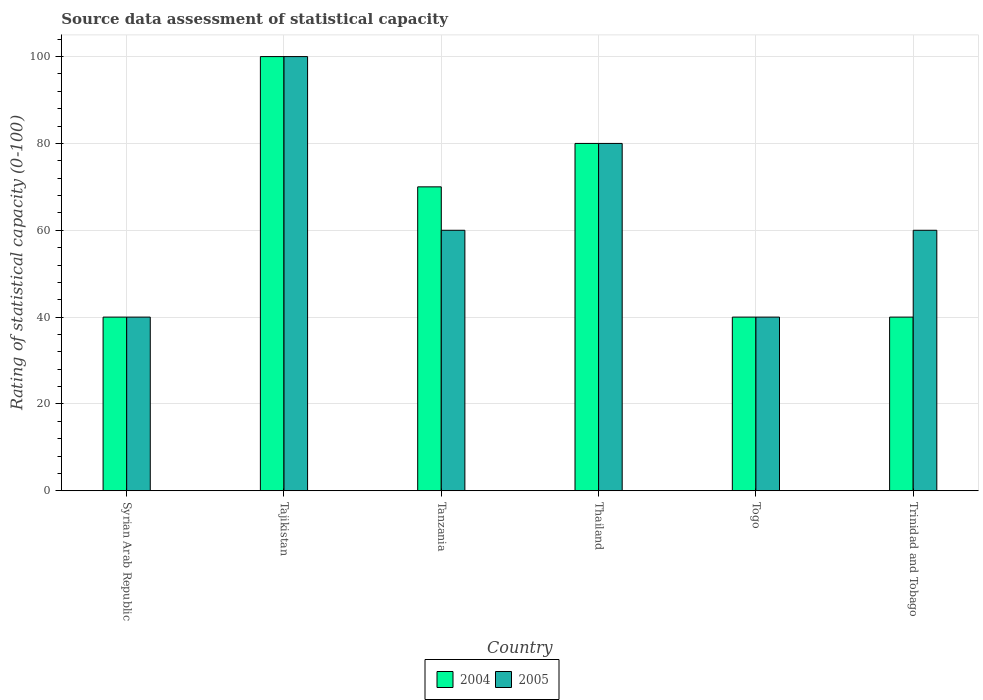Are the number of bars per tick equal to the number of legend labels?
Provide a short and direct response. Yes. What is the label of the 4th group of bars from the left?
Your answer should be very brief. Thailand. In which country was the rating of statistical capacity in 2005 maximum?
Give a very brief answer. Tajikistan. In which country was the rating of statistical capacity in 2004 minimum?
Keep it short and to the point. Syrian Arab Republic. What is the total rating of statistical capacity in 2005 in the graph?
Offer a very short reply. 380. What is the average rating of statistical capacity in 2004 per country?
Offer a terse response. 61.67. What is the ratio of the rating of statistical capacity in 2004 in Thailand to that in Trinidad and Tobago?
Provide a short and direct response. 2. Is the difference between the rating of statistical capacity in 2005 in Tajikistan and Thailand greater than the difference between the rating of statistical capacity in 2004 in Tajikistan and Thailand?
Provide a short and direct response. No. What is the difference between the highest and the second highest rating of statistical capacity in 2004?
Offer a very short reply. -20. Is the sum of the rating of statistical capacity in 2004 in Tajikistan and Thailand greater than the maximum rating of statistical capacity in 2005 across all countries?
Give a very brief answer. Yes. What does the 2nd bar from the left in Thailand represents?
Provide a succinct answer. 2005. How many bars are there?
Ensure brevity in your answer.  12. Are all the bars in the graph horizontal?
Your answer should be very brief. No. What is the difference between two consecutive major ticks on the Y-axis?
Give a very brief answer. 20. Are the values on the major ticks of Y-axis written in scientific E-notation?
Provide a succinct answer. No. Does the graph contain any zero values?
Give a very brief answer. No. Where does the legend appear in the graph?
Make the answer very short. Bottom center. How are the legend labels stacked?
Offer a terse response. Horizontal. What is the title of the graph?
Your answer should be very brief. Source data assessment of statistical capacity. Does "1964" appear as one of the legend labels in the graph?
Make the answer very short. No. What is the label or title of the Y-axis?
Your response must be concise. Rating of statistical capacity (0-100). What is the Rating of statistical capacity (0-100) in 2005 in Syrian Arab Republic?
Ensure brevity in your answer.  40. What is the Rating of statistical capacity (0-100) in 2004 in Tajikistan?
Provide a succinct answer. 100. What is the Rating of statistical capacity (0-100) of 2004 in Thailand?
Your answer should be very brief. 80. What is the Rating of statistical capacity (0-100) of 2005 in Thailand?
Keep it short and to the point. 80. What is the Rating of statistical capacity (0-100) of 2004 in Togo?
Keep it short and to the point. 40. What is the Rating of statistical capacity (0-100) in 2005 in Togo?
Your answer should be compact. 40. Across all countries, what is the minimum Rating of statistical capacity (0-100) in 2005?
Offer a terse response. 40. What is the total Rating of statistical capacity (0-100) in 2004 in the graph?
Offer a very short reply. 370. What is the total Rating of statistical capacity (0-100) in 2005 in the graph?
Your answer should be compact. 380. What is the difference between the Rating of statistical capacity (0-100) in 2004 in Syrian Arab Republic and that in Tajikistan?
Your answer should be very brief. -60. What is the difference between the Rating of statistical capacity (0-100) in 2005 in Syrian Arab Republic and that in Tajikistan?
Offer a terse response. -60. What is the difference between the Rating of statistical capacity (0-100) of 2004 in Syrian Arab Republic and that in Tanzania?
Provide a short and direct response. -30. What is the difference between the Rating of statistical capacity (0-100) in 2005 in Syrian Arab Republic and that in Thailand?
Provide a succinct answer. -40. What is the difference between the Rating of statistical capacity (0-100) of 2005 in Syrian Arab Republic and that in Togo?
Your answer should be compact. 0. What is the difference between the Rating of statistical capacity (0-100) of 2004 in Syrian Arab Republic and that in Trinidad and Tobago?
Ensure brevity in your answer.  0. What is the difference between the Rating of statistical capacity (0-100) of 2005 in Syrian Arab Republic and that in Trinidad and Tobago?
Your answer should be compact. -20. What is the difference between the Rating of statistical capacity (0-100) in 2004 in Tajikistan and that in Tanzania?
Give a very brief answer. 30. What is the difference between the Rating of statistical capacity (0-100) of 2005 in Tajikistan and that in Tanzania?
Give a very brief answer. 40. What is the difference between the Rating of statistical capacity (0-100) in 2005 in Tajikistan and that in Togo?
Provide a succinct answer. 60. What is the difference between the Rating of statistical capacity (0-100) in 2004 in Tajikistan and that in Trinidad and Tobago?
Make the answer very short. 60. What is the difference between the Rating of statistical capacity (0-100) of 2005 in Tajikistan and that in Trinidad and Tobago?
Your response must be concise. 40. What is the difference between the Rating of statistical capacity (0-100) of 2005 in Tanzania and that in Togo?
Your response must be concise. 20. What is the difference between the Rating of statistical capacity (0-100) in 2005 in Tanzania and that in Trinidad and Tobago?
Your answer should be compact. 0. What is the difference between the Rating of statistical capacity (0-100) of 2004 in Thailand and that in Trinidad and Tobago?
Give a very brief answer. 40. What is the difference between the Rating of statistical capacity (0-100) of 2005 in Thailand and that in Trinidad and Tobago?
Your answer should be compact. 20. What is the difference between the Rating of statistical capacity (0-100) of 2004 in Togo and that in Trinidad and Tobago?
Offer a very short reply. 0. What is the difference between the Rating of statistical capacity (0-100) of 2004 in Syrian Arab Republic and the Rating of statistical capacity (0-100) of 2005 in Tajikistan?
Keep it short and to the point. -60. What is the difference between the Rating of statistical capacity (0-100) of 2004 in Syrian Arab Republic and the Rating of statistical capacity (0-100) of 2005 in Thailand?
Provide a succinct answer. -40. What is the difference between the Rating of statistical capacity (0-100) in 2004 in Syrian Arab Republic and the Rating of statistical capacity (0-100) in 2005 in Togo?
Give a very brief answer. 0. What is the difference between the Rating of statistical capacity (0-100) of 2004 in Tajikistan and the Rating of statistical capacity (0-100) of 2005 in Tanzania?
Provide a succinct answer. 40. What is the difference between the Rating of statistical capacity (0-100) in 2004 in Tajikistan and the Rating of statistical capacity (0-100) in 2005 in Trinidad and Tobago?
Offer a terse response. 40. What is the difference between the Rating of statistical capacity (0-100) in 2004 in Tanzania and the Rating of statistical capacity (0-100) in 2005 in Togo?
Your answer should be compact. 30. What is the difference between the Rating of statistical capacity (0-100) of 2004 in Togo and the Rating of statistical capacity (0-100) of 2005 in Trinidad and Tobago?
Give a very brief answer. -20. What is the average Rating of statistical capacity (0-100) in 2004 per country?
Provide a short and direct response. 61.67. What is the average Rating of statistical capacity (0-100) of 2005 per country?
Your response must be concise. 63.33. What is the difference between the Rating of statistical capacity (0-100) of 2004 and Rating of statistical capacity (0-100) of 2005 in Tajikistan?
Keep it short and to the point. 0. What is the difference between the Rating of statistical capacity (0-100) of 2004 and Rating of statistical capacity (0-100) of 2005 in Togo?
Provide a short and direct response. 0. What is the difference between the Rating of statistical capacity (0-100) in 2004 and Rating of statistical capacity (0-100) in 2005 in Trinidad and Tobago?
Keep it short and to the point. -20. What is the ratio of the Rating of statistical capacity (0-100) of 2004 in Syrian Arab Republic to that in Tajikistan?
Offer a terse response. 0.4. What is the ratio of the Rating of statistical capacity (0-100) in 2005 in Syrian Arab Republic to that in Tanzania?
Your response must be concise. 0.67. What is the ratio of the Rating of statistical capacity (0-100) in 2005 in Syrian Arab Republic to that in Togo?
Your answer should be very brief. 1. What is the ratio of the Rating of statistical capacity (0-100) of 2004 in Syrian Arab Republic to that in Trinidad and Tobago?
Give a very brief answer. 1. What is the ratio of the Rating of statistical capacity (0-100) of 2005 in Syrian Arab Republic to that in Trinidad and Tobago?
Give a very brief answer. 0.67. What is the ratio of the Rating of statistical capacity (0-100) in 2004 in Tajikistan to that in Tanzania?
Keep it short and to the point. 1.43. What is the ratio of the Rating of statistical capacity (0-100) of 2005 in Tajikistan to that in Tanzania?
Ensure brevity in your answer.  1.67. What is the ratio of the Rating of statistical capacity (0-100) in 2004 in Tajikistan to that in Togo?
Provide a short and direct response. 2.5. What is the ratio of the Rating of statistical capacity (0-100) in 2004 in Tajikistan to that in Trinidad and Tobago?
Provide a succinct answer. 2.5. What is the ratio of the Rating of statistical capacity (0-100) in 2005 in Tanzania to that in Thailand?
Make the answer very short. 0.75. What is the ratio of the Rating of statistical capacity (0-100) in 2005 in Tanzania to that in Togo?
Provide a short and direct response. 1.5. What is the ratio of the Rating of statistical capacity (0-100) in 2005 in Tanzania to that in Trinidad and Tobago?
Your response must be concise. 1. What is the ratio of the Rating of statistical capacity (0-100) of 2005 in Thailand to that in Trinidad and Tobago?
Offer a terse response. 1.33. What is the difference between the highest and the second highest Rating of statistical capacity (0-100) of 2004?
Your answer should be compact. 20. 